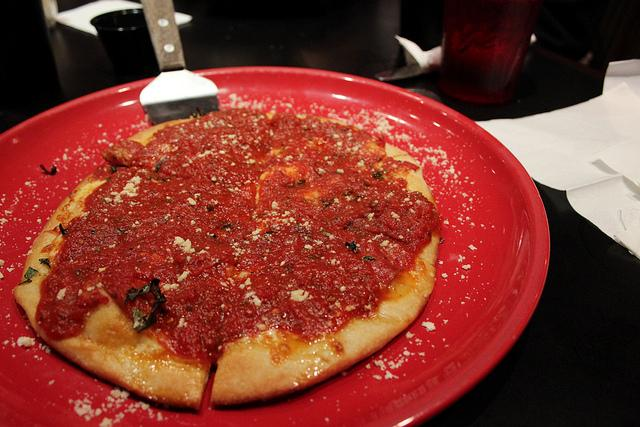What is there an excessive amount of relative to most pizzas? Please explain your reasoning. sauce. Tomato from the look of it. 